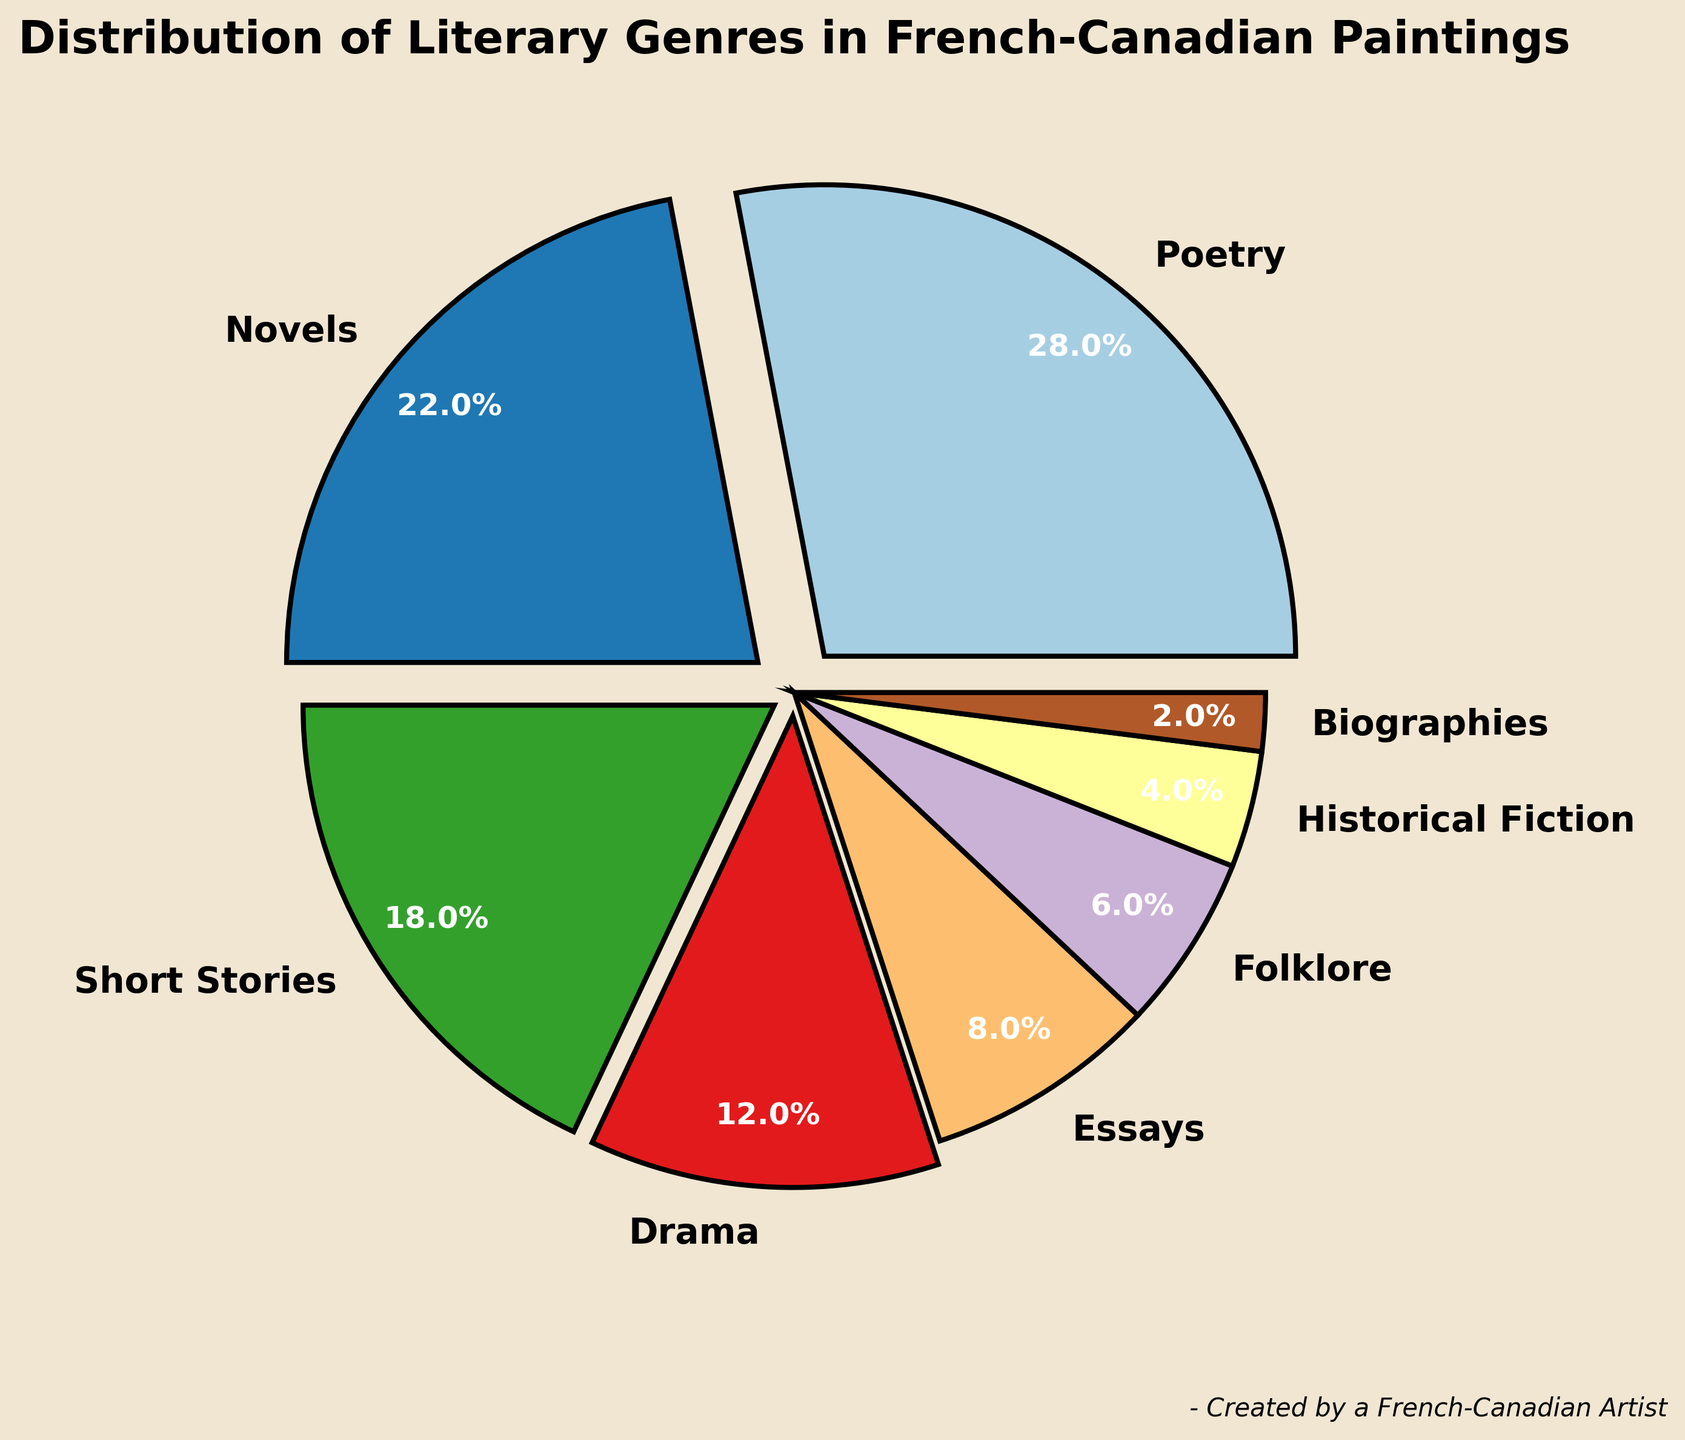What's the most common literary genre used in French-Canadian paintings? The genre with the highest percentage represents the most common literary genre. According to the figure, "Poetry" has the highest percentage at 28%.
Answer: Poetry Which is more common in these paintings, Essays or Short Stories? Comparing the percentages of Essays (8%) and Short Stories (18%), we see that Short Stories have a higher percentage.
Answer: Short Stories How many genres have a proportion greater than or equal to 15%? We need to count the genres with a percentage of 15 or more. These genres are Poetry (28%), Novels (22%), and Short Stories (18%). So, there are 3 such genres.
Answer: 3 What is the difference in percentage between the most common genre and the least common genre? The most common genre is Poetry (28%) and the least common is Biographies (2%). The difference is 28% - 2% = 26%.
Answer: 26% What is the total percentage of genres with less than 10% representation? The genres with less than 10% are Essays (8%), Folklore (6%), Historical Fiction (4%), and Biographies (2%). The sum is 8% + 6% + 4% + 2% = 20%.
Answer: 20% Does Drama have a higher or lower percentage than Novels? Comparing the percentages of Drama (12%) and Novels (22%), Drama has a lower percentage.
Answer: Lower Which genre has the boldest visual emphasis in the figure, and why? The genre with the highest percentage, Poetry (28%), has the boldest visual emphasis due to the size of its pie slice and the applied explode effect that visually separates it from the rest.
Answer: Poetry What can you observe about the visual representation of genres with a percentage of 10% or more? Genres with 10% or more are Poetry, Novels, Short Stories, and Drama. These slices are larger and have explode effects to make them stand out more prominently in the pie chart.
Answer: Larger slices with explode effects What is the combined percentage of all genres contributing less than 5% individually? The only genre with less than 5% is Biographies (2%). Therefore, the combined percentage is 2%.
Answer: 2% Which genre is represented by the smallest pie slice? The percentage data shows that Biographies have the smallest percentage at 2%, hence represented by the smallest pie slice.
Answer: Biographies 